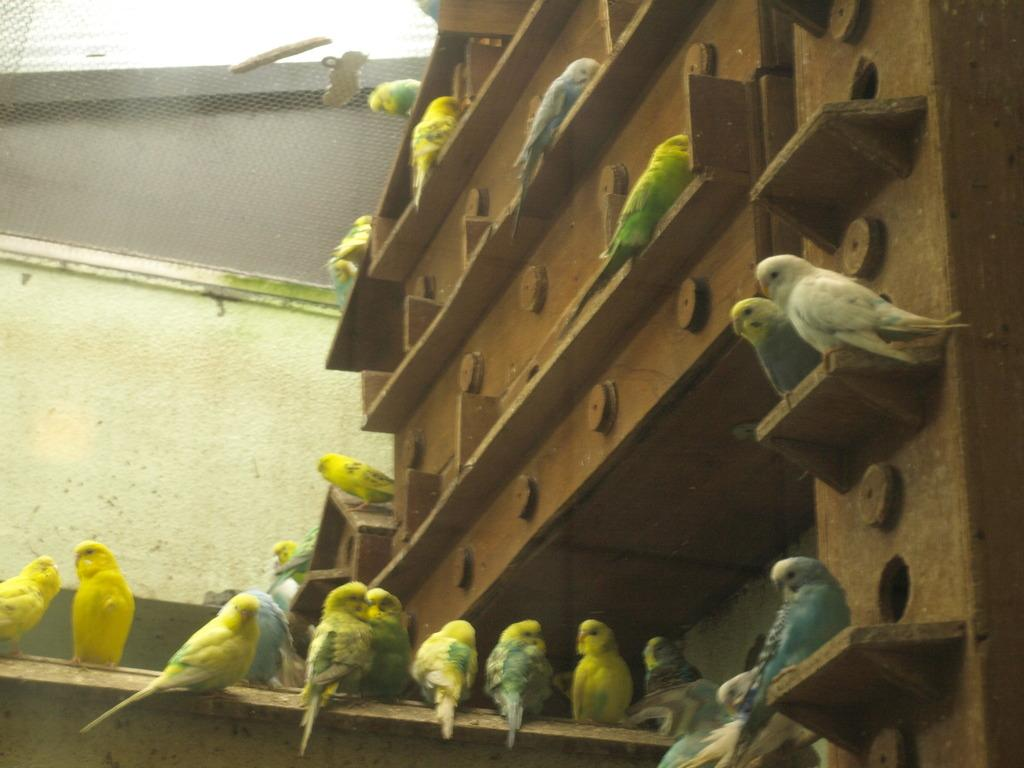What type of animals are present in the image? There are colorful birds in the image. What are the birds perched on? The birds are on brown color wooden planks. What can be seen in the background of the image? There is a wall visible in the image. What are the netted things in the image used for? The purpose of the netted things in the image is not specified, but they could be used for various purposes such as birdcages or decoration. What type of lamp is hanging from the guitar in the image? There is no lamp or guitar present in the image; it features colorful birds on wooden planks with a wall in the background and netted things. 